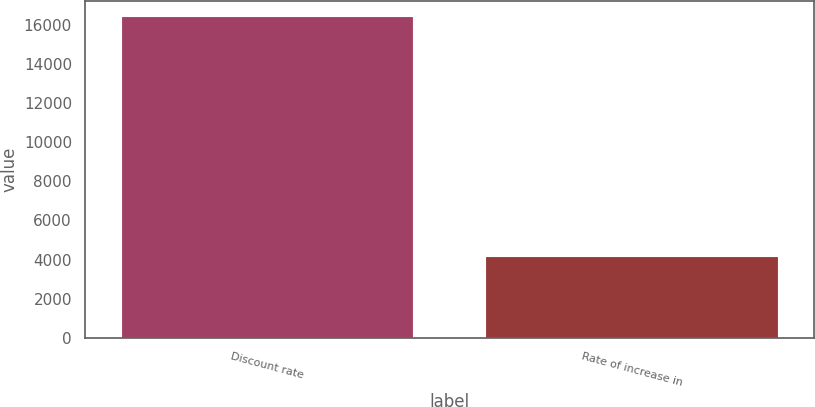Convert chart. <chart><loc_0><loc_0><loc_500><loc_500><bar_chart><fcel>Discount rate<fcel>Rate of increase in<nl><fcel>16385<fcel>4157<nl></chart> 